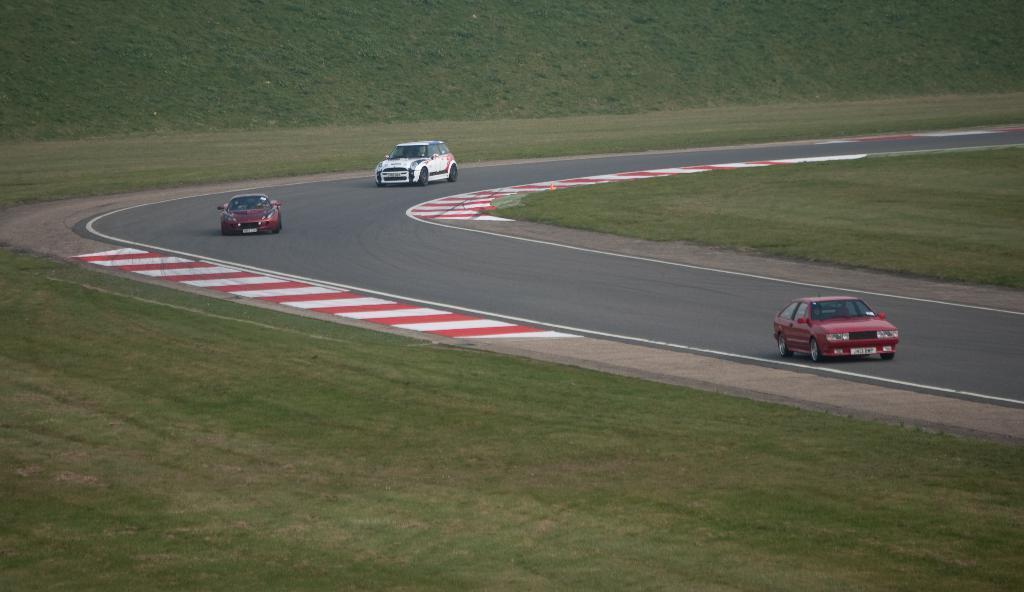In one or two sentences, can you explain what this image depicts? In this image I can see 3 cars on the road. There is grass on the either sides of the road. 